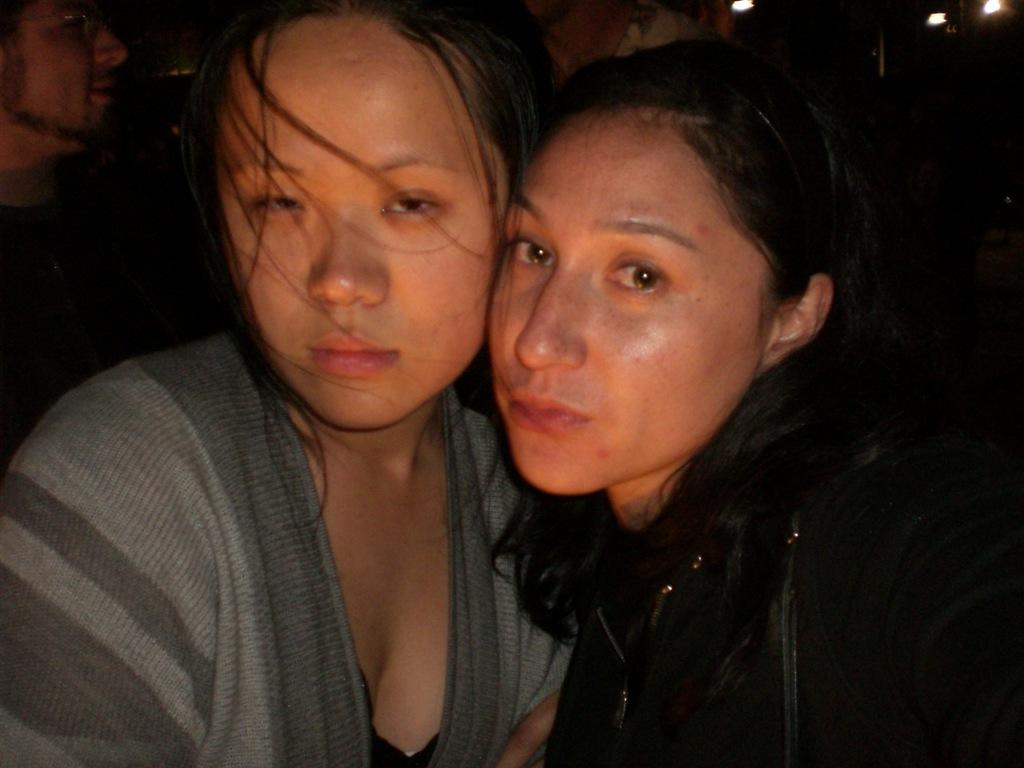How many people are in the image? There are a few people in the image. What can be observed about the background of the image? The background of the image is dark. What type of instrument is being played by the elbow in the image? There is no instrument being played by an elbow in the image, as elbows are not capable of playing instruments. 